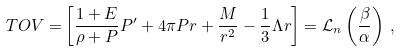<formula> <loc_0><loc_0><loc_500><loc_500>T O V = & \left [ \frac { 1 + E } { \rho + P } P ^ { \prime } + 4 \pi P r + \frac { M } { r ^ { 2 } } - \frac { 1 } { 3 } \Lambda r \right ] = \mathcal { L } _ { n } \left ( \frac { \beta } { \alpha } \right ) \, ,</formula> 